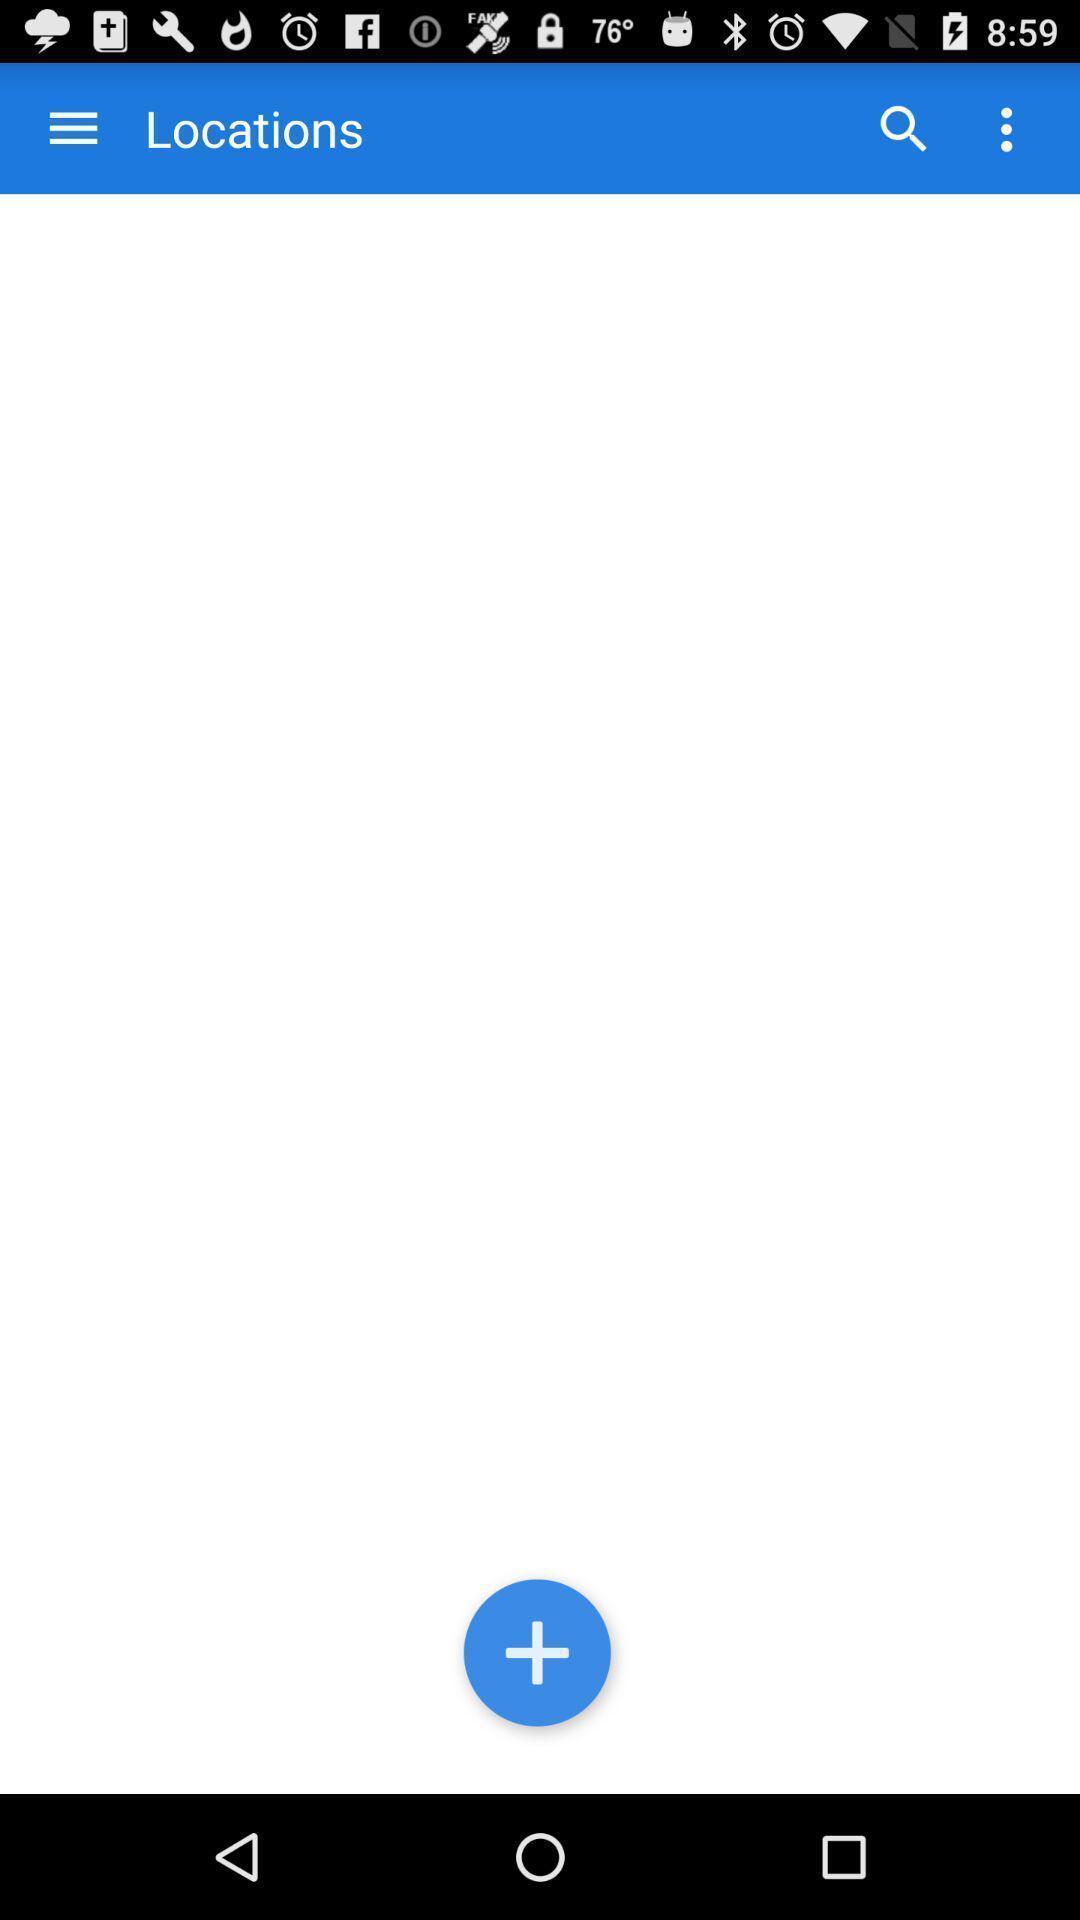Give me a narrative description of this picture. Page displaying to add locations. 